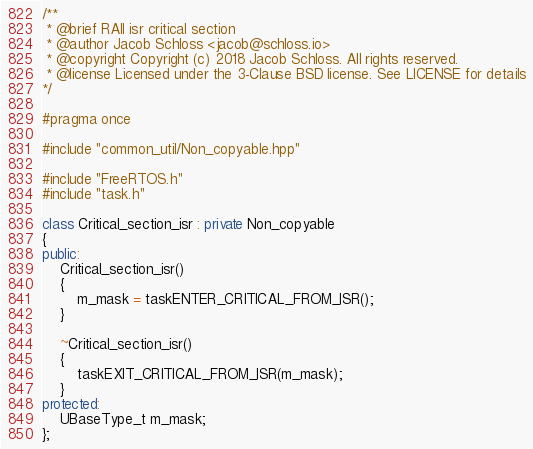<code> <loc_0><loc_0><loc_500><loc_500><_C++_>/**
 * @brief RAII isr critical section
 * @author Jacob Schloss <jacob@schloss.io>
 * @copyright Copyright (c) 2018 Jacob Schloss. All rights reserved.
 * @license Licensed under the 3-Clause BSD license. See LICENSE for details
*/

#pragma once

#include "common_util/Non_copyable.hpp"

#include "FreeRTOS.h"
#include "task.h"

class Critical_section_isr : private Non_copyable
{
public:
	Critical_section_isr()
	{
		m_mask = taskENTER_CRITICAL_FROM_ISR();
	}

	~Critical_section_isr()
	{
		taskEXIT_CRITICAL_FROM_ISR(m_mask);
	}
protected:
	UBaseType_t m_mask;
};</code> 